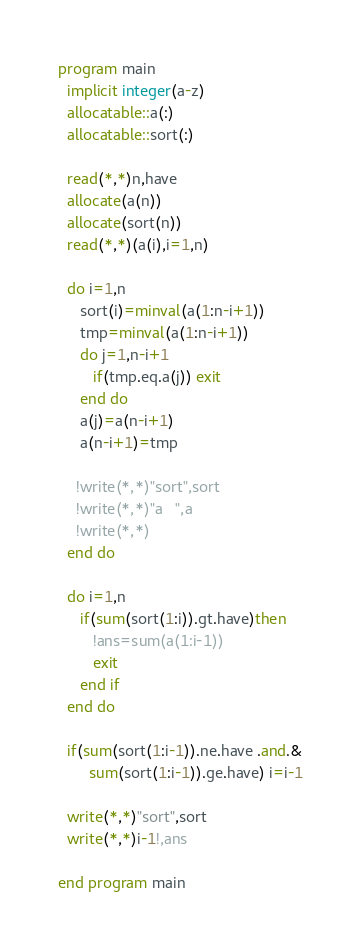Convert code to text. <code><loc_0><loc_0><loc_500><loc_500><_FORTRAN_>program main
  implicit integer(a-z)
  allocatable::a(:)
  allocatable::sort(:)

  read(*,*)n,have
  allocate(a(n))
  allocate(sort(n))
  read(*,*)(a(i),i=1,n)

  do i=1,n
     sort(i)=minval(a(1:n-i+1))
     tmp=minval(a(1:n-i+1))
     do j=1,n-i+1
        if(tmp.eq.a(j)) exit
     end do
     a(j)=a(n-i+1)
     a(n-i+1)=tmp
     
    !write(*,*)"sort",sort
    !write(*,*)"a   ",a
    !write(*,*)
  end do

  do i=1,n
     if(sum(sort(1:i)).gt.have)then
        !ans=sum(a(1:i-1))
        exit
     end if
  end do
  
  if(sum(sort(1:i-1)).ne.have .and.&
       sum(sort(1:i-1)).ge.have) i=i-1
  
  write(*,*)"sort",sort
  write(*,*)i-1!,ans

end program main
</code> 